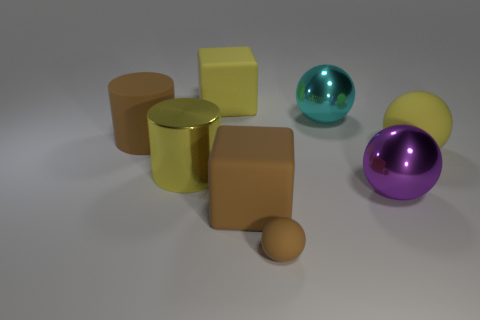What is the color of the big matte thing that is left of the brown cube and in front of the big yellow matte block? The big matte object to the left of the brown cube and in front of the large yellow block appears to be gold or a golden yellow, exhibiting a metallic sheen rather than a flat matte finish. 